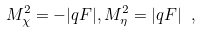Convert formula to latex. <formula><loc_0><loc_0><loc_500><loc_500>M ^ { 2 } _ { \chi } = - | q F | , M ^ { 2 } _ { \eta } = | q F | \ ,</formula> 